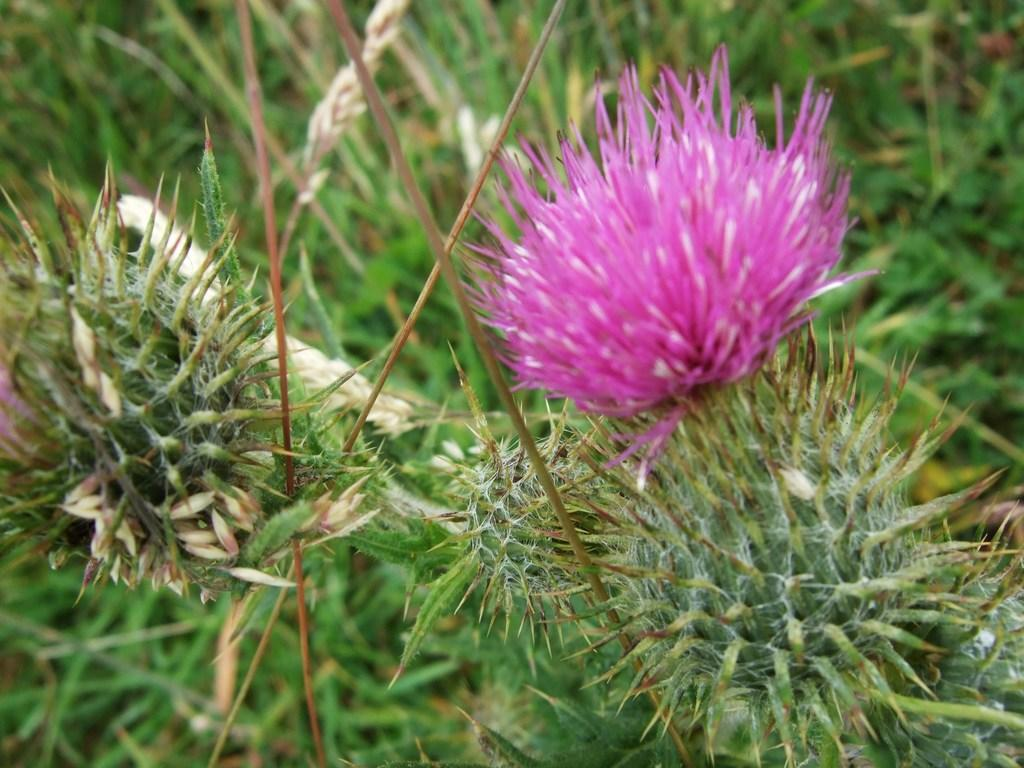What color is the flower in the image? The flower in the image is pink. What type of vegetation is present in the image besides the flower? There are green trees around in the image. What type of yarn is being used to create the history of the flower in the image? There is no yarn or history of the flower present in the image; it simply shows a pink flower and green trees. 